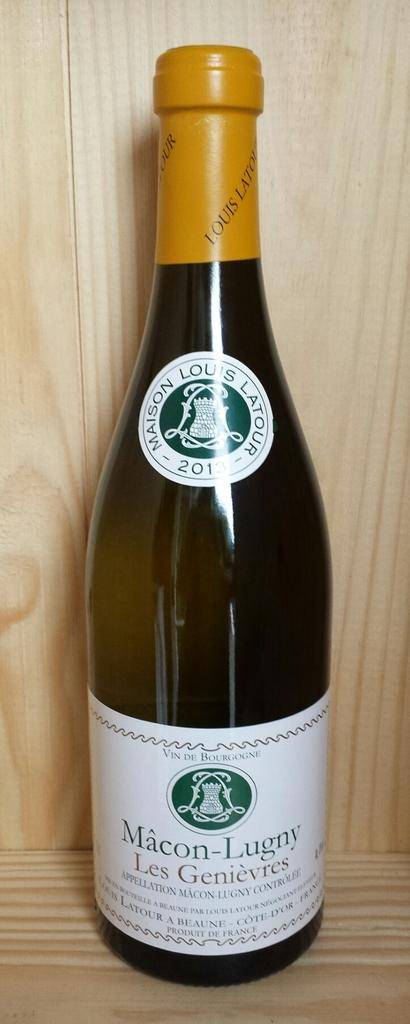Provide a one-sentence caption for the provided image. A bottle of Macon Lugny wine that is still corked. 